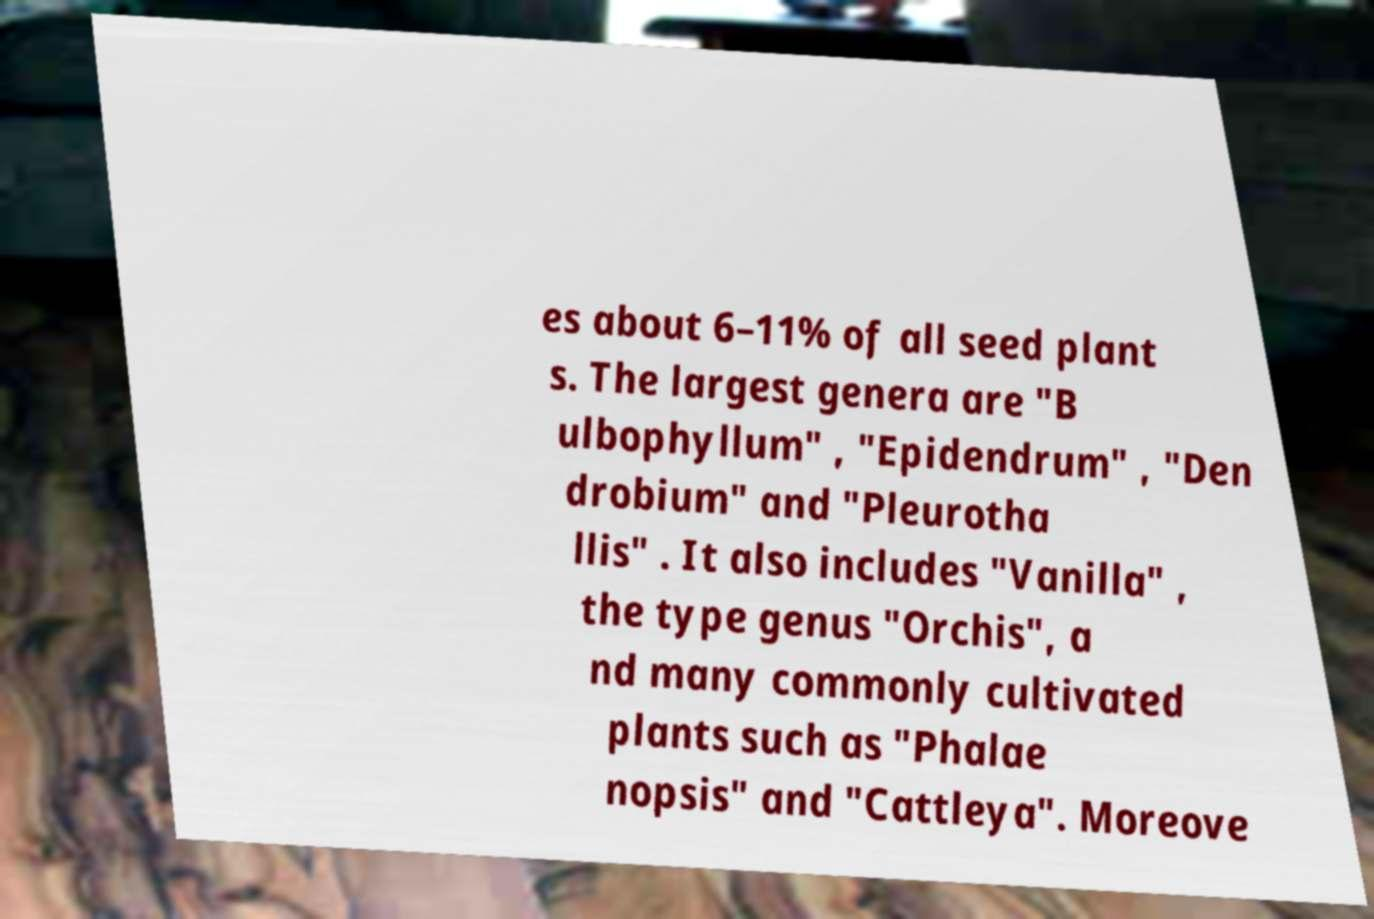Can you accurately transcribe the text from the provided image for me? es about 6–11% of all seed plant s. The largest genera are "B ulbophyllum" , "Epidendrum" , "Den drobium" and "Pleurotha llis" . It also includes "Vanilla" , the type genus "Orchis", a nd many commonly cultivated plants such as "Phalae nopsis" and "Cattleya". Moreove 